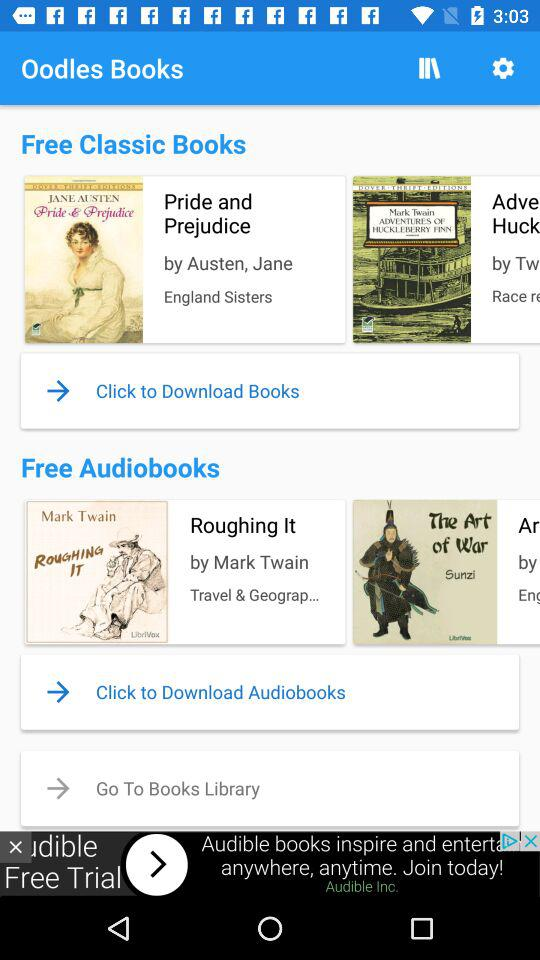What are the free classic books? The free classic books are "Pride and Prejudice" and "ADVENTURES OF HUCKLEBERRY FINN". 